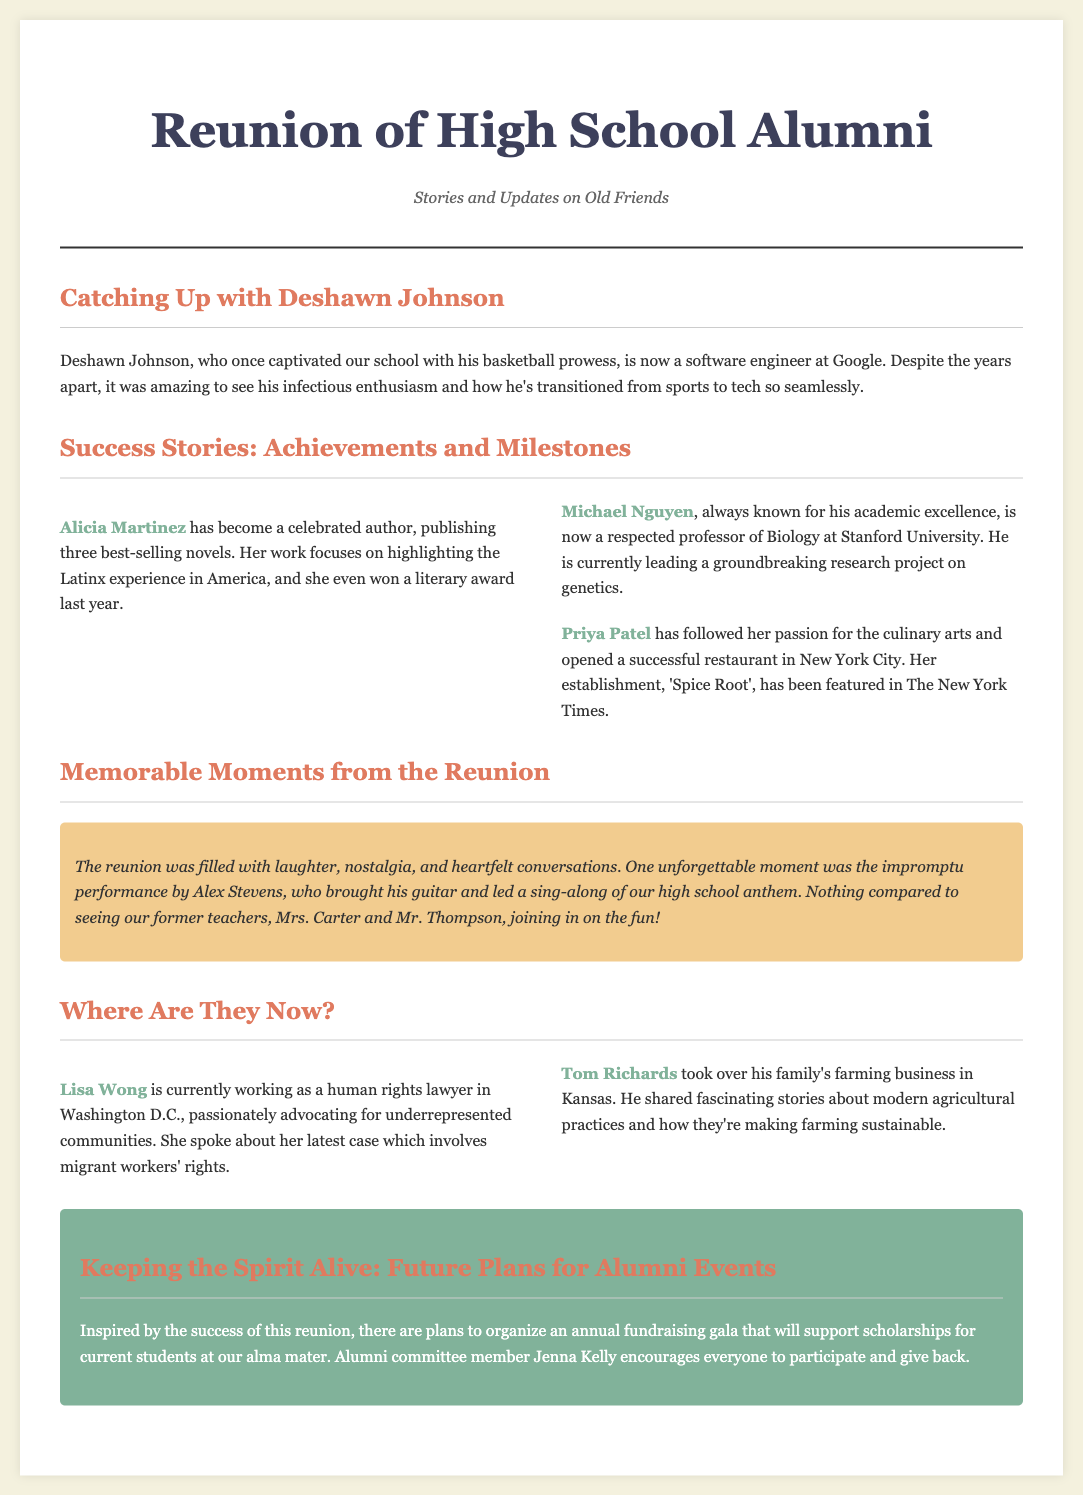what is Deshawn Johnson’s current job? The document states that Deshawn Johnson is now a software engineer at Google.
Answer: software engineer at Google who is a celebrated author mentioned in the document? The document mentions Alicia Martinez as a celebrated author who has published three best-selling novels.
Answer: Alicia Martinez what is Michael Nguyen known for? Michael Nguyen is known for his academic excellence and is now a respected professor of Biology at Stanford University.
Answer: respected professor of Biology at Stanford University what was one memorable moment from the reunion? The document describes an unforgettable moment as the impromptu performance by Alex Stevens, who led a sing-along of their high school anthem.
Answer: impromptu performance by Alex Stevens where is Lisa Wong working? Lisa Wong is currently working as a human rights lawyer in Washington D.C.
Answer: human rights lawyer in Washington D.C what future event is being planned for alumni? An annual fundraising gala is planned to support scholarships for current students at their alma mater.
Answer: annual fundraising gala how many best-selling novels has Alicia Martinez published? Alicia Martinez has published three best-selling novels according to the document.
Answer: three what is Priya Patel’s restaurant called? The document states that Priya Patel’s restaurant is called 'Spice Root'.
Answer: 'Spice Root' who encouraged participation in future alumni events? The document identifies Jenna Kelly as the one who encourages everyone to participate in future alumni events.
Answer: Jenna Kelly 